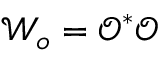Convert formula to latex. <formula><loc_0><loc_0><loc_500><loc_500>\mathcal { W } _ { o } = \ m a t h s c r { O } ^ { * } \ m a t h s c r { O }</formula> 